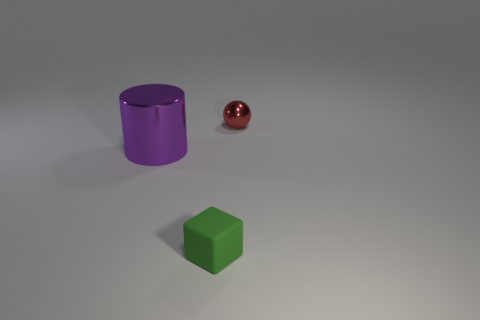Do the rubber thing and the cylinder have the same size?
Offer a very short reply. No. What material is the large purple thing?
Ensure brevity in your answer.  Metal. There is a thing that is the same size as the shiny ball; what is it made of?
Provide a succinct answer. Rubber. Is there a red sphere of the same size as the matte thing?
Provide a succinct answer. Yes. Are there an equal number of small rubber cubes to the right of the tiny rubber thing and small metal things on the right side of the tiny red ball?
Keep it short and to the point. Yes. Are there more big purple metal things than big cyan matte balls?
Give a very brief answer. Yes. What number of metal things are either tiny green cubes or red spheres?
Offer a terse response. 1. How many other tiny rubber things have the same color as the rubber thing?
Give a very brief answer. 0. What is the material of the small thing that is in front of the ball behind the tiny thing in front of the red shiny object?
Give a very brief answer. Rubber. There is a object that is in front of the purple shiny object behind the small matte object; what color is it?
Your answer should be compact. Green. 